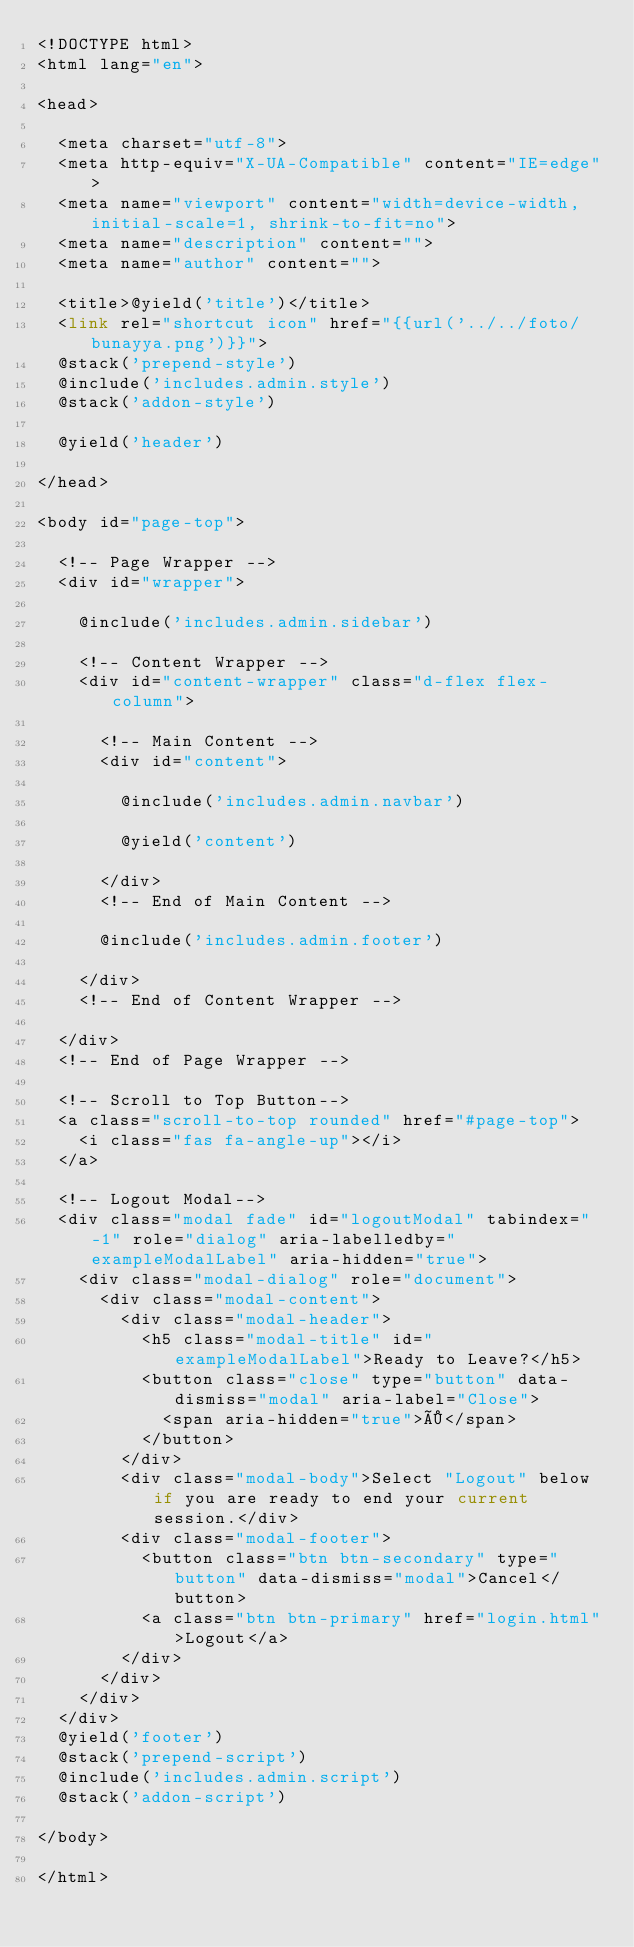Convert code to text. <code><loc_0><loc_0><loc_500><loc_500><_PHP_><!DOCTYPE html>
<html lang="en">

<head>

  <meta charset="utf-8">
  <meta http-equiv="X-UA-Compatible" content="IE=edge">
  <meta name="viewport" content="width=device-width, initial-scale=1, shrink-to-fit=no">
  <meta name="description" content="">
  <meta name="author" content="">

  <title>@yield('title')</title>
  <link rel="shortcut icon" href="{{url('../../foto/bunayya.png')}}">
  @stack('prepend-style')
  @include('includes.admin.style')
  @stack('addon-style')

  @yield('header')

</head>

<body id="page-top">

  <!-- Page Wrapper -->
  <div id="wrapper">

    @include('includes.admin.sidebar')

    <!-- Content Wrapper -->
    <div id="content-wrapper" class="d-flex flex-column">

      <!-- Main Content -->
      <div id="content">

        @include('includes.admin.navbar')

        @yield('content')

      </div>
      <!-- End of Main Content -->

      @include('includes.admin.footer')

    </div>
    <!-- End of Content Wrapper -->

  </div>
  <!-- End of Page Wrapper -->

  <!-- Scroll to Top Button-->
  <a class="scroll-to-top rounded" href="#page-top">
    <i class="fas fa-angle-up"></i>
  </a>

  <!-- Logout Modal-->
  <div class="modal fade" id="logoutModal" tabindex="-1" role="dialog" aria-labelledby="exampleModalLabel" aria-hidden="true">
    <div class="modal-dialog" role="document">
      <div class="modal-content">
        <div class="modal-header">
          <h5 class="modal-title" id="exampleModalLabel">Ready to Leave?</h5>
          <button class="close" type="button" data-dismiss="modal" aria-label="Close">
            <span aria-hidden="true">×</span>
          </button>
        </div>
        <div class="modal-body">Select "Logout" below if you are ready to end your current session.</div>
        <div class="modal-footer">
          <button class="btn btn-secondary" type="button" data-dismiss="modal">Cancel</button>
          <a class="btn btn-primary" href="login.html">Logout</a>
        </div>
      </div>
    </div>
  </div>
  @yield('footer')
  @stack('prepend-script')
  @include('includes.admin.script')
  @stack('addon-script')

</body>

</html>
</code> 